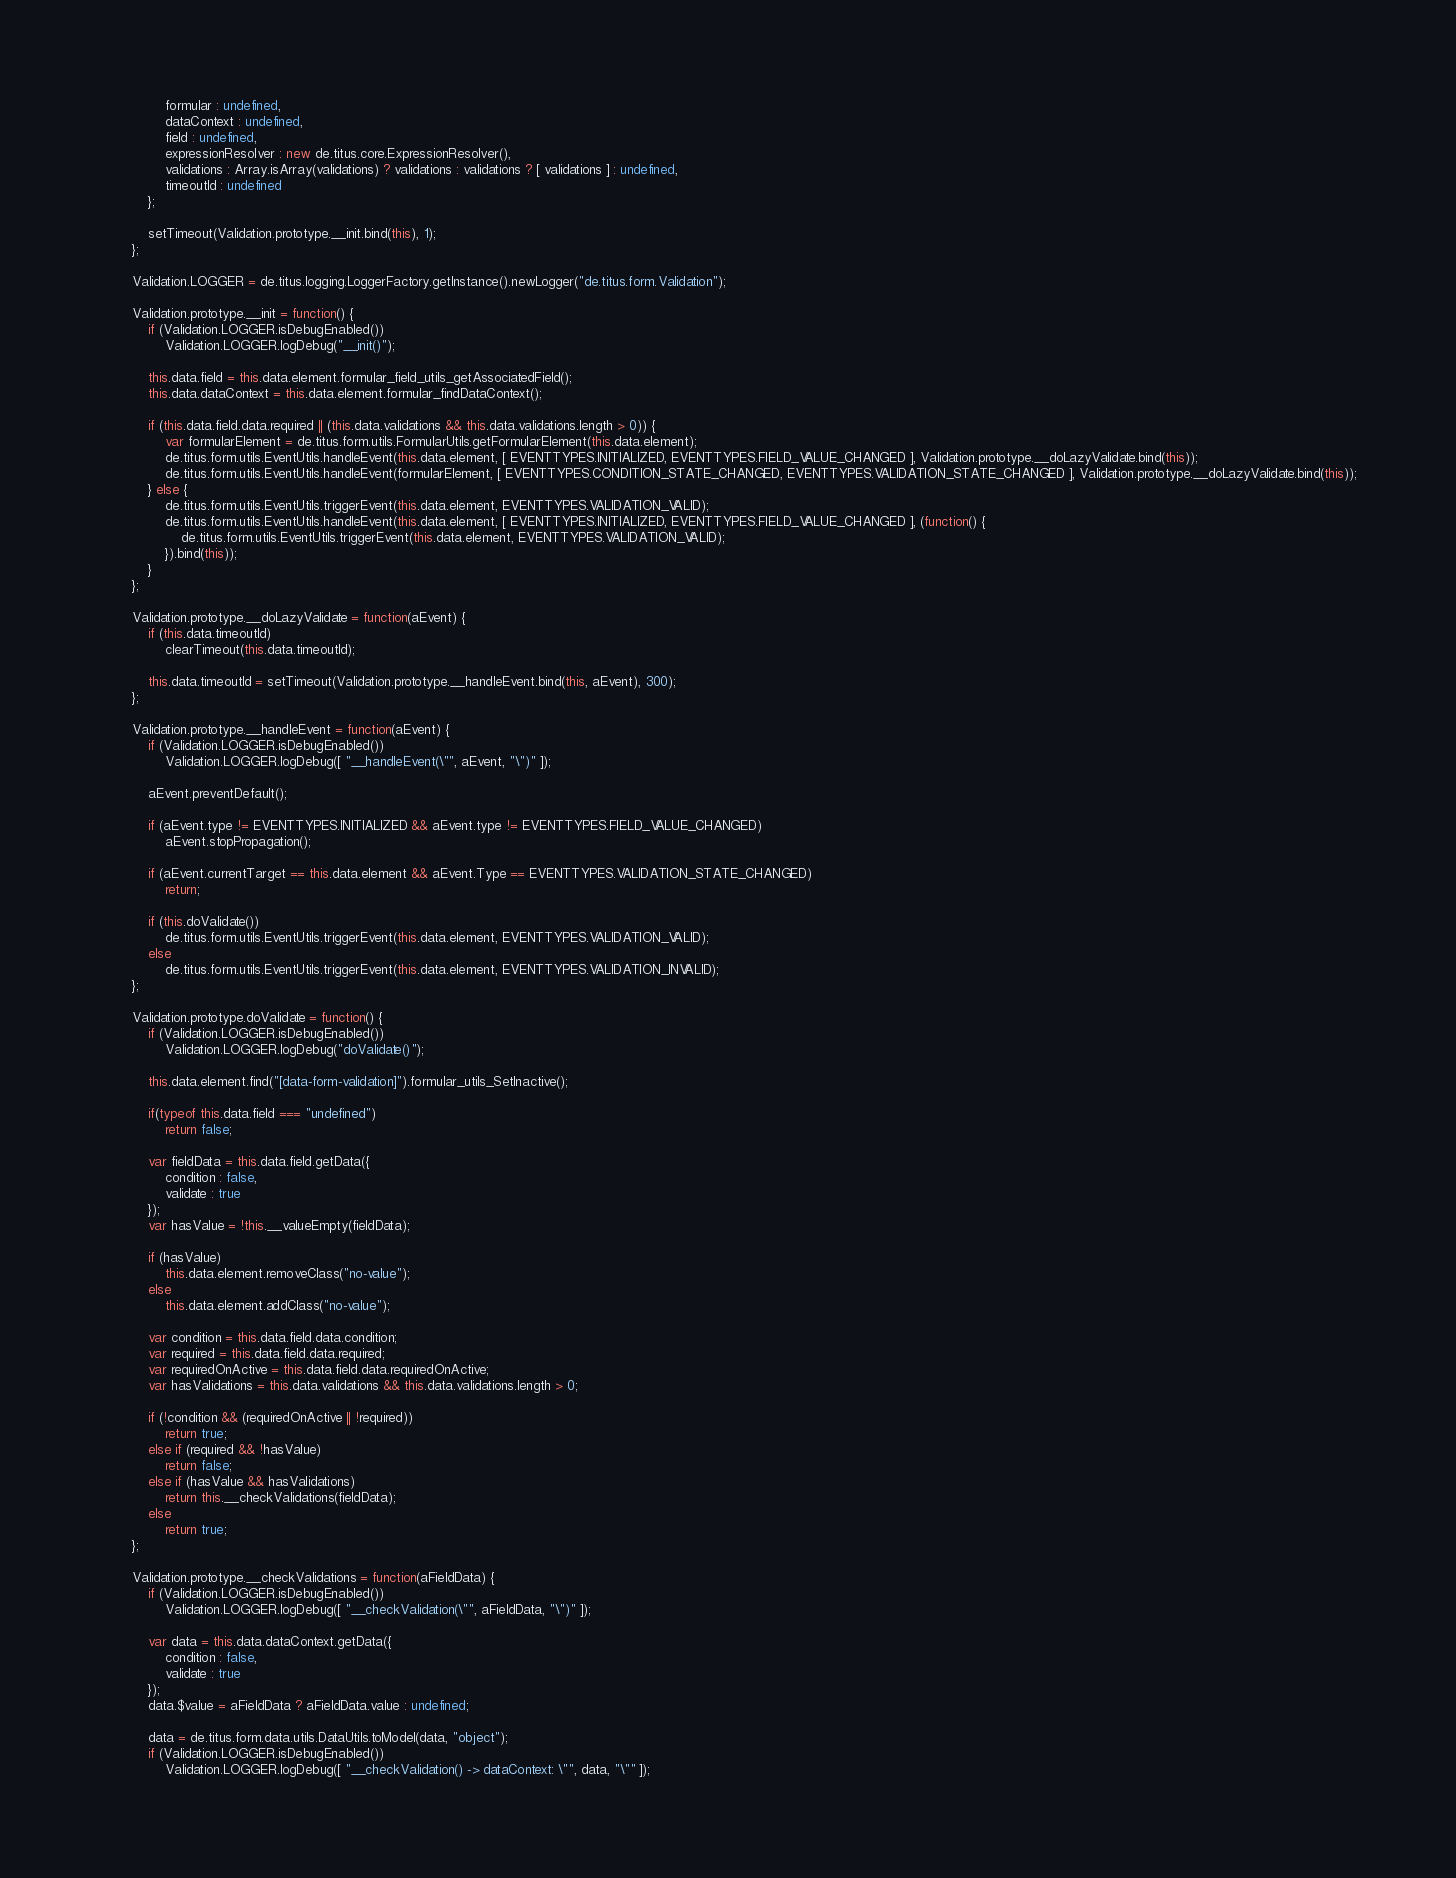Convert code to text. <code><loc_0><loc_0><loc_500><loc_500><_JavaScript_>			    formular : undefined,
			    dataContext : undefined,
			    field : undefined,
			    expressionResolver : new de.titus.core.ExpressionResolver(),
			    validations : Array.isArray(validations) ? validations : validations ? [ validations ] : undefined,
			    timeoutId : undefined
			};

			setTimeout(Validation.prototype.__init.bind(this), 1);
		};

		Validation.LOGGER = de.titus.logging.LoggerFactory.getInstance().newLogger("de.titus.form.Validation");

		Validation.prototype.__init = function() {
			if (Validation.LOGGER.isDebugEnabled())
				Validation.LOGGER.logDebug("__init()");

			this.data.field = this.data.element.formular_field_utils_getAssociatedField();
			this.data.dataContext = this.data.element.formular_findDataContext();

			if (this.data.field.data.required || (this.data.validations && this.data.validations.length > 0)) {
				var formularElement = de.titus.form.utils.FormularUtils.getFormularElement(this.data.element);
				de.titus.form.utils.EventUtils.handleEvent(this.data.element, [ EVENTTYPES.INITIALIZED, EVENTTYPES.FIELD_VALUE_CHANGED ], Validation.prototype.__doLazyValidate.bind(this));
				de.titus.form.utils.EventUtils.handleEvent(formularElement, [ EVENTTYPES.CONDITION_STATE_CHANGED, EVENTTYPES.VALIDATION_STATE_CHANGED ], Validation.prototype.__doLazyValidate.bind(this));
			} else {
				de.titus.form.utils.EventUtils.triggerEvent(this.data.element, EVENTTYPES.VALIDATION_VALID);
				de.titus.form.utils.EventUtils.handleEvent(this.data.element, [ EVENTTYPES.INITIALIZED, EVENTTYPES.FIELD_VALUE_CHANGED ], (function() {
					de.titus.form.utils.EventUtils.triggerEvent(this.data.element, EVENTTYPES.VALIDATION_VALID);
				}).bind(this));
			}
		};

		Validation.prototype.__doLazyValidate = function(aEvent) {
			if (this.data.timeoutId)
				clearTimeout(this.data.timeoutId);

			this.data.timeoutId = setTimeout(Validation.prototype.__handleEvent.bind(this, aEvent), 300);
		};

		Validation.prototype.__handleEvent = function(aEvent) {
			if (Validation.LOGGER.isDebugEnabled())
				Validation.LOGGER.logDebug([ "__handleEvent(\"", aEvent, "\")" ]);

			aEvent.preventDefault();

			if (aEvent.type != EVENTTYPES.INITIALIZED && aEvent.type != EVENTTYPES.FIELD_VALUE_CHANGED)
				aEvent.stopPropagation();

			if (aEvent.currentTarget == this.data.element && aEvent.Type == EVENTTYPES.VALIDATION_STATE_CHANGED)
				return;

			if (this.doValidate())
				de.titus.form.utils.EventUtils.triggerEvent(this.data.element, EVENTTYPES.VALIDATION_VALID);
			else
				de.titus.form.utils.EventUtils.triggerEvent(this.data.element, EVENTTYPES.VALIDATION_INVALID);
		};

		Validation.prototype.doValidate = function() {
			if (Validation.LOGGER.isDebugEnabled())
				Validation.LOGGER.logDebug("doValidate()");

			this.data.element.find("[data-form-validation]").formular_utils_SetInactive();

			if(typeof this.data.field === "undefined")
				return false;
			
			var fieldData = this.data.field.getData({
			    condition : false,
			    validate : true
			});
			var hasValue = !this.__valueEmpty(fieldData);

			if (hasValue)
				this.data.element.removeClass("no-value");
			else
				this.data.element.addClass("no-value");

			var condition = this.data.field.data.condition;
			var required = this.data.field.data.required;
			var requiredOnActive = this.data.field.data.requiredOnActive;
			var hasValidations = this.data.validations && this.data.validations.length > 0;

			if (!condition && (requiredOnActive || !required))
				return true;
			else if (required && !hasValue)
				return false;
			else if (hasValue && hasValidations)
				return this.__checkValidations(fieldData);
			else
				return true;
		};

		Validation.prototype.__checkValidations = function(aFieldData) {
			if (Validation.LOGGER.isDebugEnabled())
				Validation.LOGGER.logDebug([ "__checkValidation(\"", aFieldData, "\")" ]);

			var data = this.data.dataContext.getData({
			    condition : false,
			    validate : true
			});
			data.$value = aFieldData ? aFieldData.value : undefined;

			data = de.titus.form.data.utils.DataUtils.toModel(data, "object");
			if (Validation.LOGGER.isDebugEnabled())
				Validation.LOGGER.logDebug([ "__checkValidation() -> dataContext: \"", data, "\"" ]);
</code> 